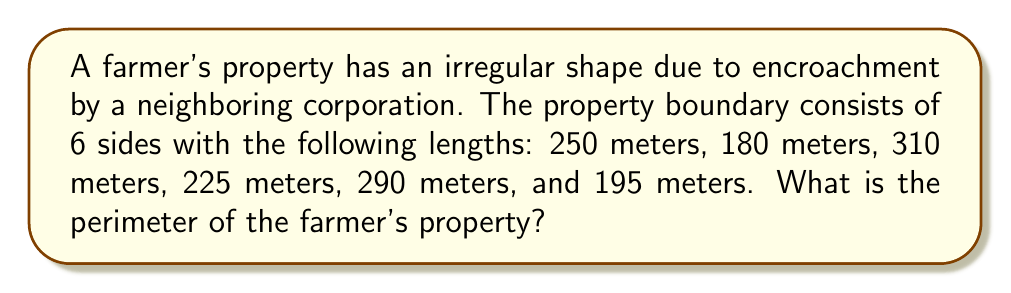Give your solution to this math problem. To determine the perimeter of the farmer's property, we need to sum up the lengths of all sides of the boundary. Let's approach this step-by-step:

1. List all the given side lengths:
   - Side 1: 250 meters
   - Side 2: 180 meters
   - Side 3: 310 meters
   - Side 4: 225 meters
   - Side 5: 290 meters
   - Side 6: 195 meters

2. Use the formula for perimeter, which is the sum of all side lengths:

   $$P = s_1 + s_2 + s_3 + s_4 + s_5 + s_6$$

   Where $P$ is the perimeter and $s_1, s_2, ..., s_6$ are the side lengths.

3. Substitute the given values into the formula:

   $$P = 250 + 180 + 310 + 225 + 290 + 195$$

4. Perform the addition:

   $$P = 1450$$

Therefore, the perimeter of the farmer's property is 1450 meters.
Answer: 1450 meters 